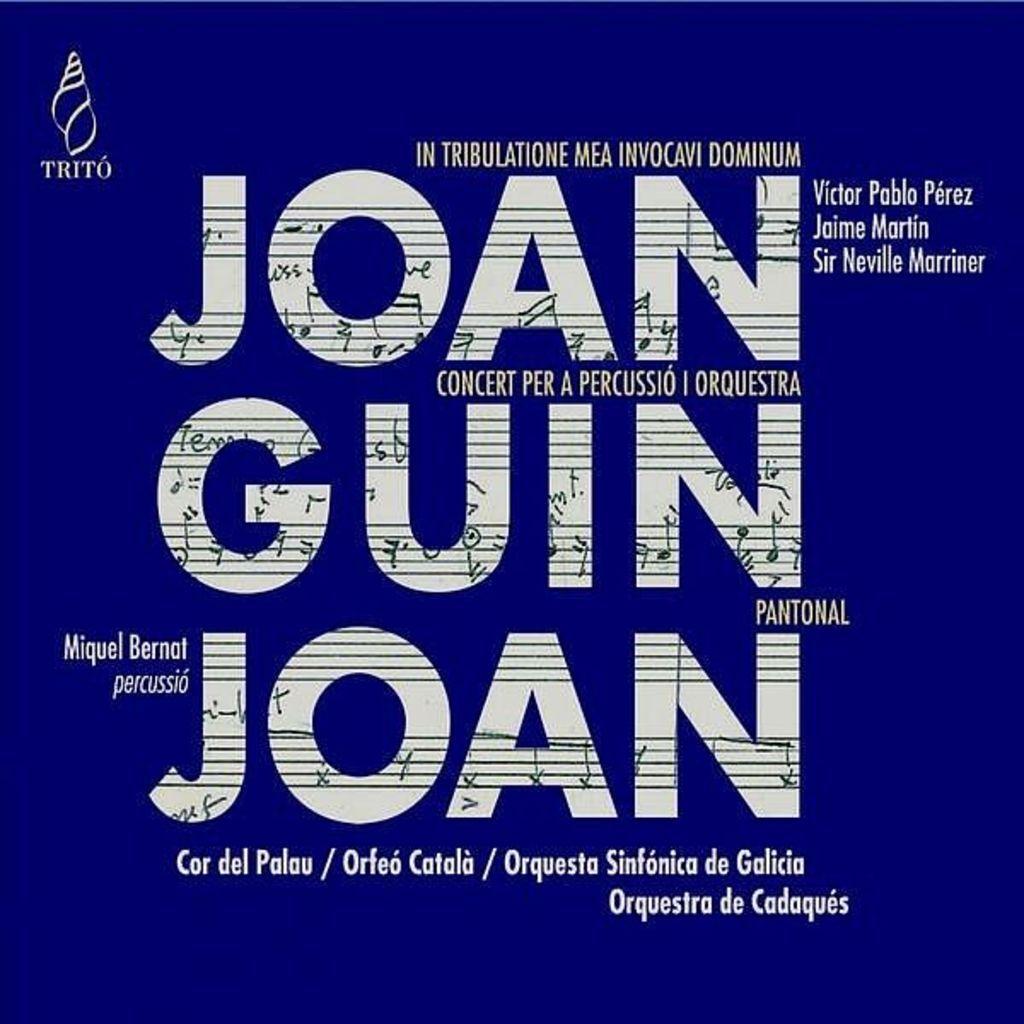Describe this image in one or two sentences. In this image, we can see a blue color poster, on that poster there is some text. 